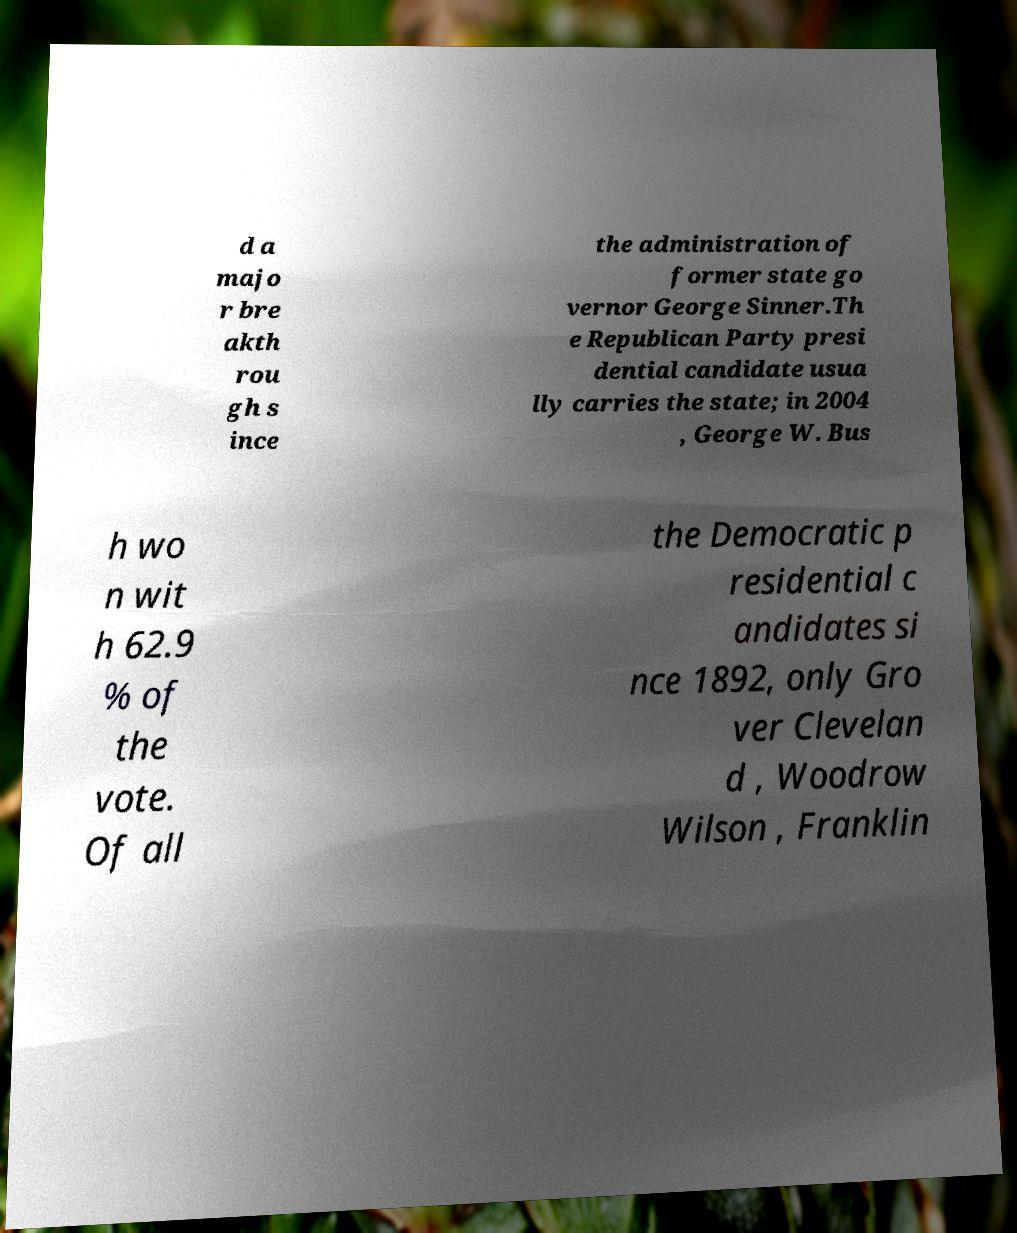There's text embedded in this image that I need extracted. Can you transcribe it verbatim? d a majo r bre akth rou gh s ince the administration of former state go vernor George Sinner.Th e Republican Party presi dential candidate usua lly carries the state; in 2004 , George W. Bus h wo n wit h 62.9 % of the vote. Of all the Democratic p residential c andidates si nce 1892, only Gro ver Clevelan d , Woodrow Wilson , Franklin 